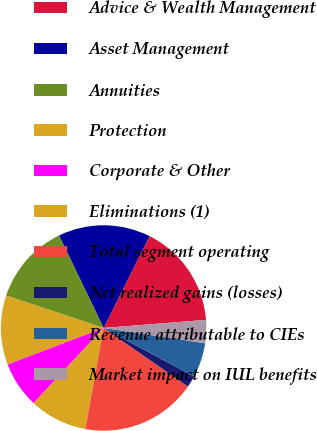<chart> <loc_0><loc_0><loc_500><loc_500><pie_chart><fcel>Advice & Wealth Management<fcel>Asset Management<fcel>Annuities<fcel>Protection<fcel>Corporate & Other<fcel>Eliminations (1)<fcel>Total segment operating<fcel>Net realized gains (losses)<fcel>Revenue attributable to CIEs<fcel>Market impact on IUL benefits<nl><fcel>16.36%<fcel>14.54%<fcel>12.73%<fcel>10.91%<fcel>7.27%<fcel>9.09%<fcel>18.18%<fcel>1.82%<fcel>5.46%<fcel>3.64%<nl></chart> 